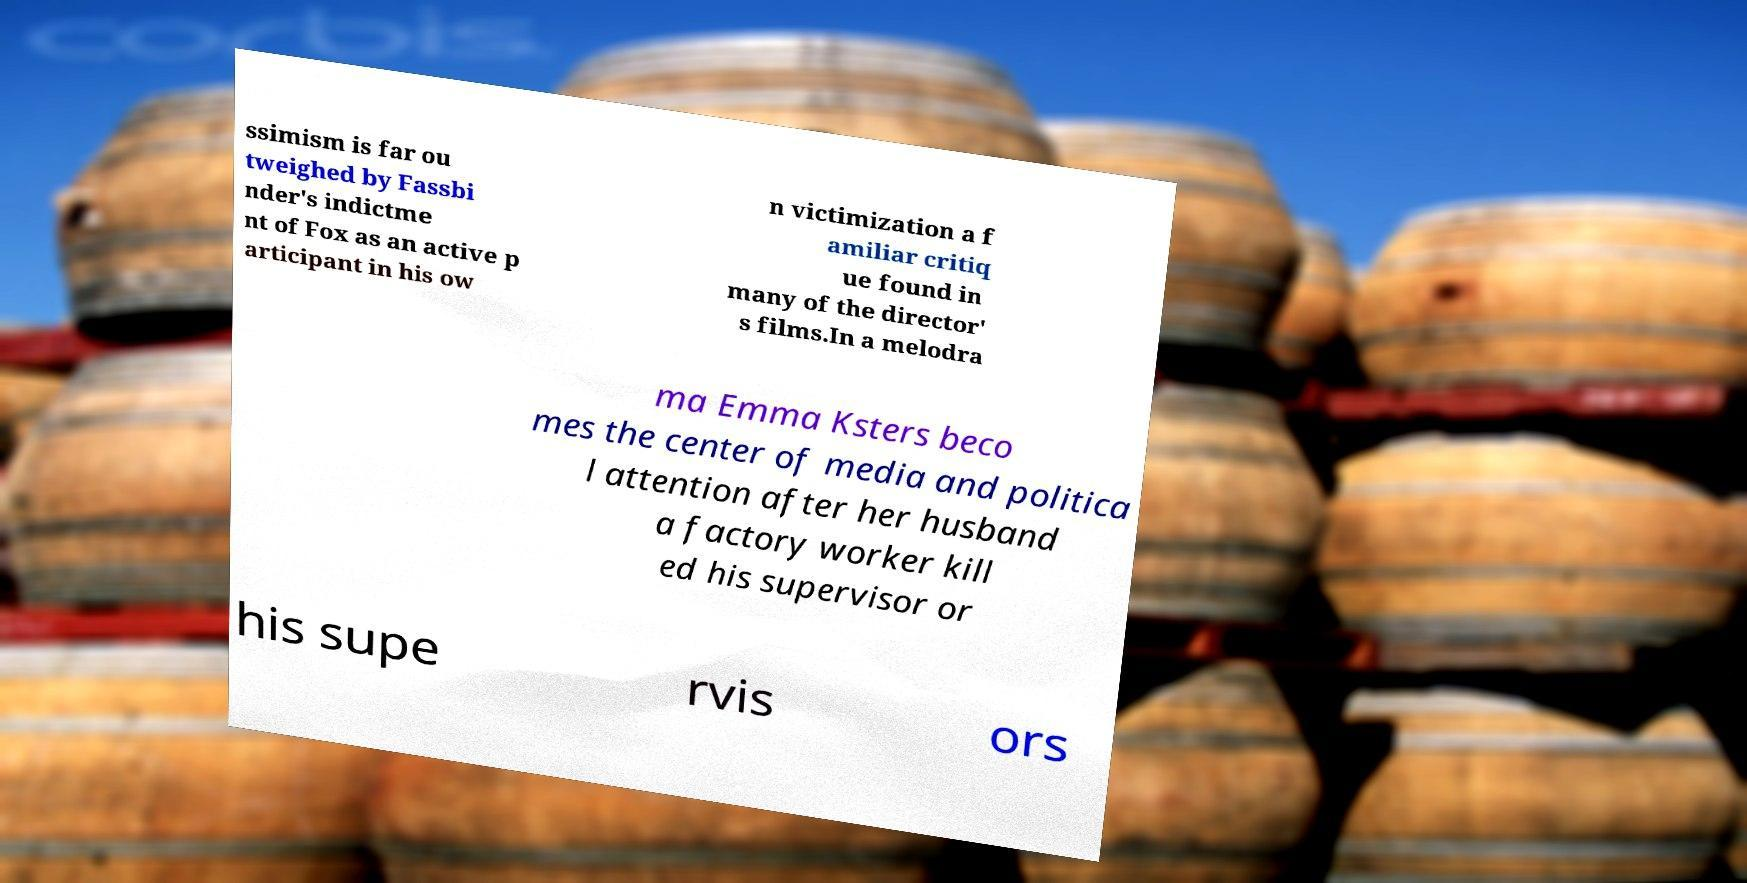Can you accurately transcribe the text from the provided image for me? ssimism is far ou tweighed by Fassbi nder's indictme nt of Fox as an active p articipant in his ow n victimization a f amiliar critiq ue found in many of the director' s films.In a melodra ma Emma Ksters beco mes the center of media and politica l attention after her husband a factory worker kill ed his supervisor or his supe rvis ors 